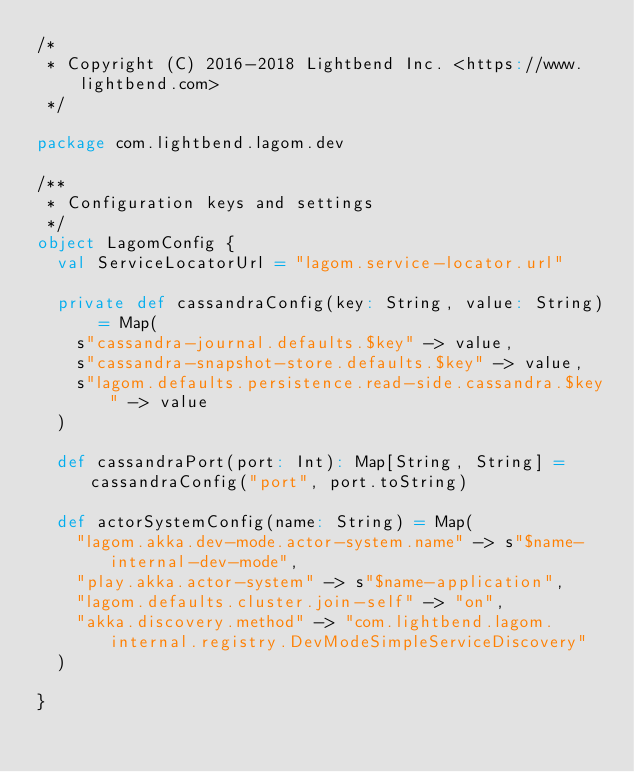Convert code to text. <code><loc_0><loc_0><loc_500><loc_500><_Scala_>/*
 * Copyright (C) 2016-2018 Lightbend Inc. <https://www.lightbend.com>
 */

package com.lightbend.lagom.dev

/**
 * Configuration keys and settings
 */
object LagomConfig {
  val ServiceLocatorUrl = "lagom.service-locator.url"

  private def cassandraConfig(key: String, value: String) = Map(
    s"cassandra-journal.defaults.$key" -> value,
    s"cassandra-snapshot-store.defaults.$key" -> value,
    s"lagom.defaults.persistence.read-side.cassandra.$key" -> value
  )

  def cassandraPort(port: Int): Map[String, String] = cassandraConfig("port", port.toString)

  def actorSystemConfig(name: String) = Map(
    "lagom.akka.dev-mode.actor-system.name" -> s"$name-internal-dev-mode",
    "play.akka.actor-system" -> s"$name-application",
    "lagom.defaults.cluster.join-self" -> "on",
    "akka.discovery.method" -> "com.lightbend.lagom.internal.registry.DevModeSimpleServiceDiscovery"
  )

}
</code> 